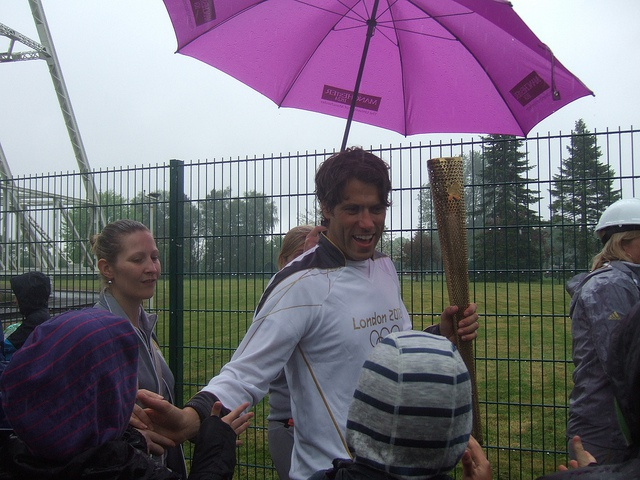Describe the objects in this image and their specific colors. I can see umbrella in white and purple tones, people in white, darkgray, gray, and black tones, people in white, black, navy, and purple tones, people in white, black, gray, and darkgray tones, and people in white, black, gray, and maroon tones in this image. 